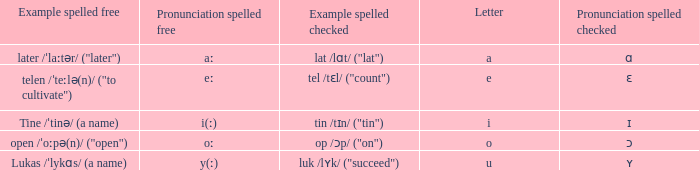Could you parse the entire table as a dict? {'header': ['Example spelled free', 'Pronunciation spelled free', 'Example spelled checked', 'Letter', 'Pronunciation spelled checked'], 'rows': [['later /ˈlaːtər/ ("later")', 'aː', 'lat /lɑt/ ("lat")', 'a', 'ɑ'], ['telen /ˈteːlə(n)/ ("to cultivate")', 'eː', 'tel /tɛl/ ("count")', 'e', 'ɛ'], ['Tine /ˈtinə/ (a name)', 'i(ː)', 'tin /tɪn/ ("tin")', 'i', 'ɪ'], ['open /ˈoːpə(n)/ ("open")', 'oː', 'op /ɔp/ ("on")', 'o', 'ɔ'], ['Lukas /ˈlykɑs/ (a name)', 'y(ː)', 'luk /lʏk/ ("succeed")', 'u', 'ʏ']]} What is Pronunciation Spelled Checked, when Example Spelled Checked is "tin /tɪn/ ("tin")" Ɪ. 